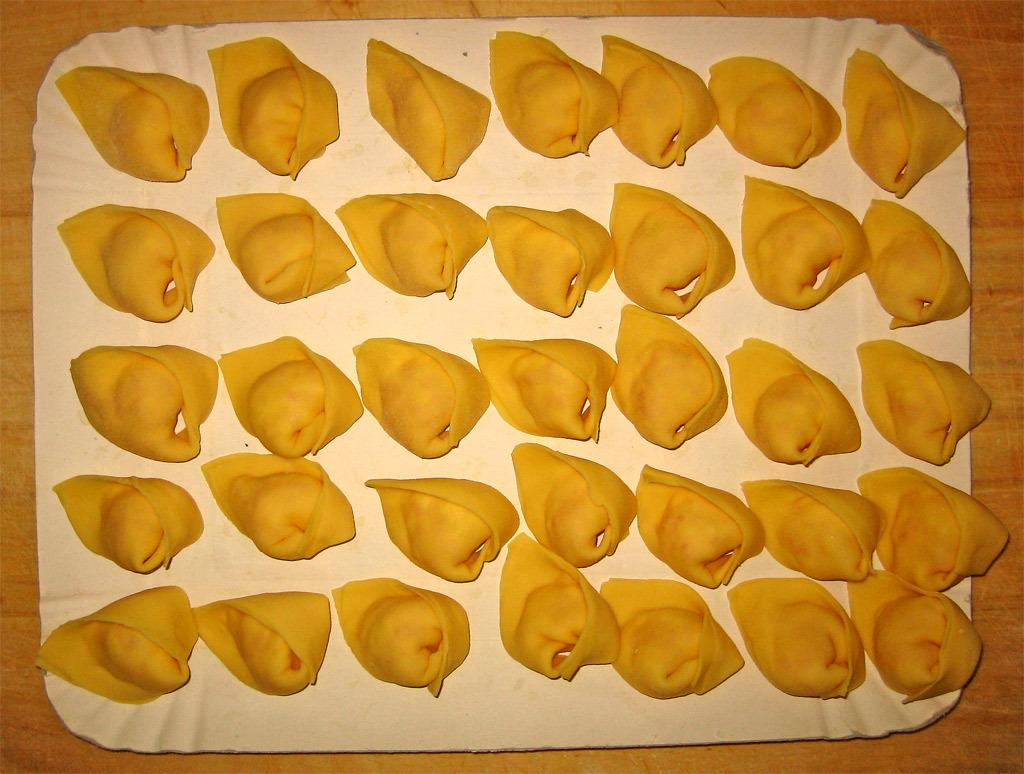What is the color of the platter in the image? The platter in the image is white. What is on the platter? The platter contains food items. On what surface is the platter placed? The platter is placed on a wooden table. Can you see a kitten playing with ink on the wooden table in the image? No, there is no kitten or ink present in the image. 